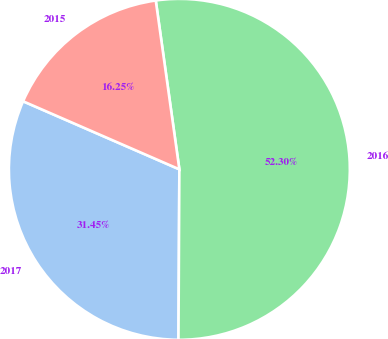Convert chart to OTSL. <chart><loc_0><loc_0><loc_500><loc_500><pie_chart><fcel>2017<fcel>2016<fcel>2015<nl><fcel>31.45%<fcel>52.29%<fcel>16.25%<nl></chart> 